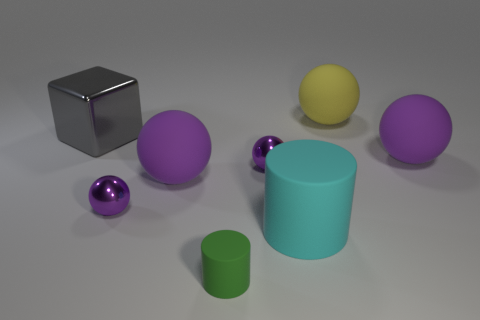Is there any other thing that has the same shape as the large gray thing?
Make the answer very short. No. What number of other objects are there of the same size as the green matte thing?
Your answer should be compact. 2. What number of other objects are the same color as the big metallic cube?
Your answer should be very brief. 0. What number of other things are there of the same shape as the large gray thing?
Make the answer very short. 0. Does the yellow matte ball have the same size as the shiny cube?
Make the answer very short. Yes. Is there a tiny thing?
Provide a succinct answer. Yes. Are there any small brown objects made of the same material as the cyan cylinder?
Provide a short and direct response. No. What material is the cyan cylinder that is the same size as the gray thing?
Your answer should be compact. Rubber. What number of other things have the same shape as the tiny rubber thing?
Offer a very short reply. 1. There is a cyan thing that is the same material as the green cylinder; what is its size?
Your answer should be very brief. Large. 